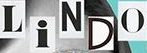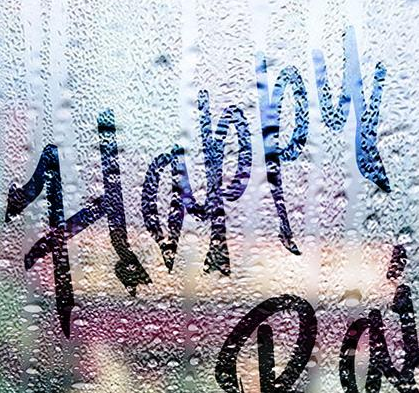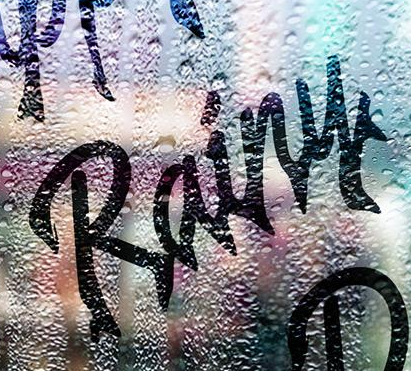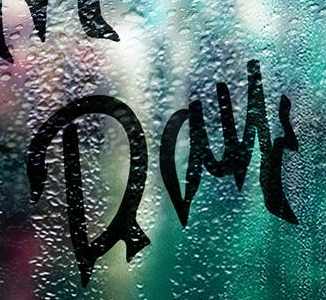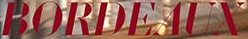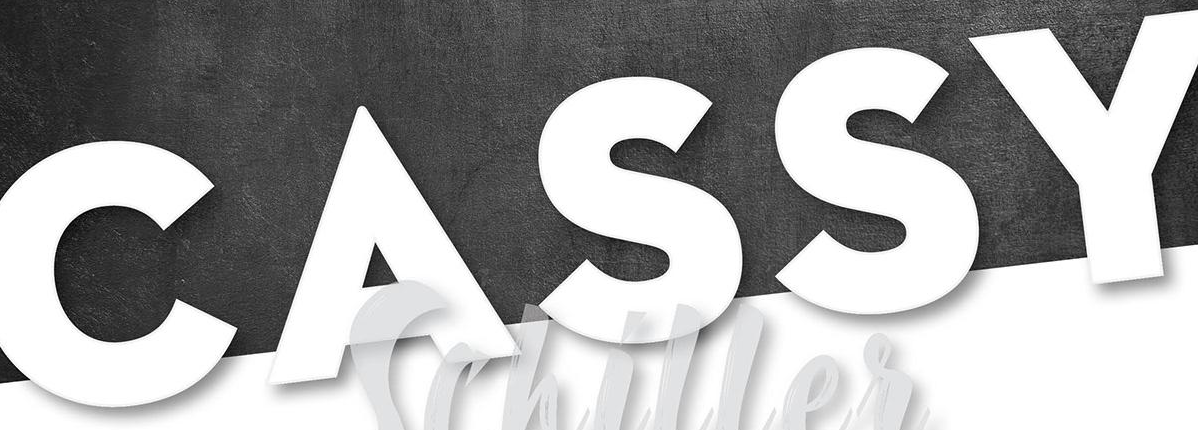Read the text from these images in sequence, separated by a semicolon. LiNDO; Happy; Rainy; Day; BORDEAUX; CASSY 